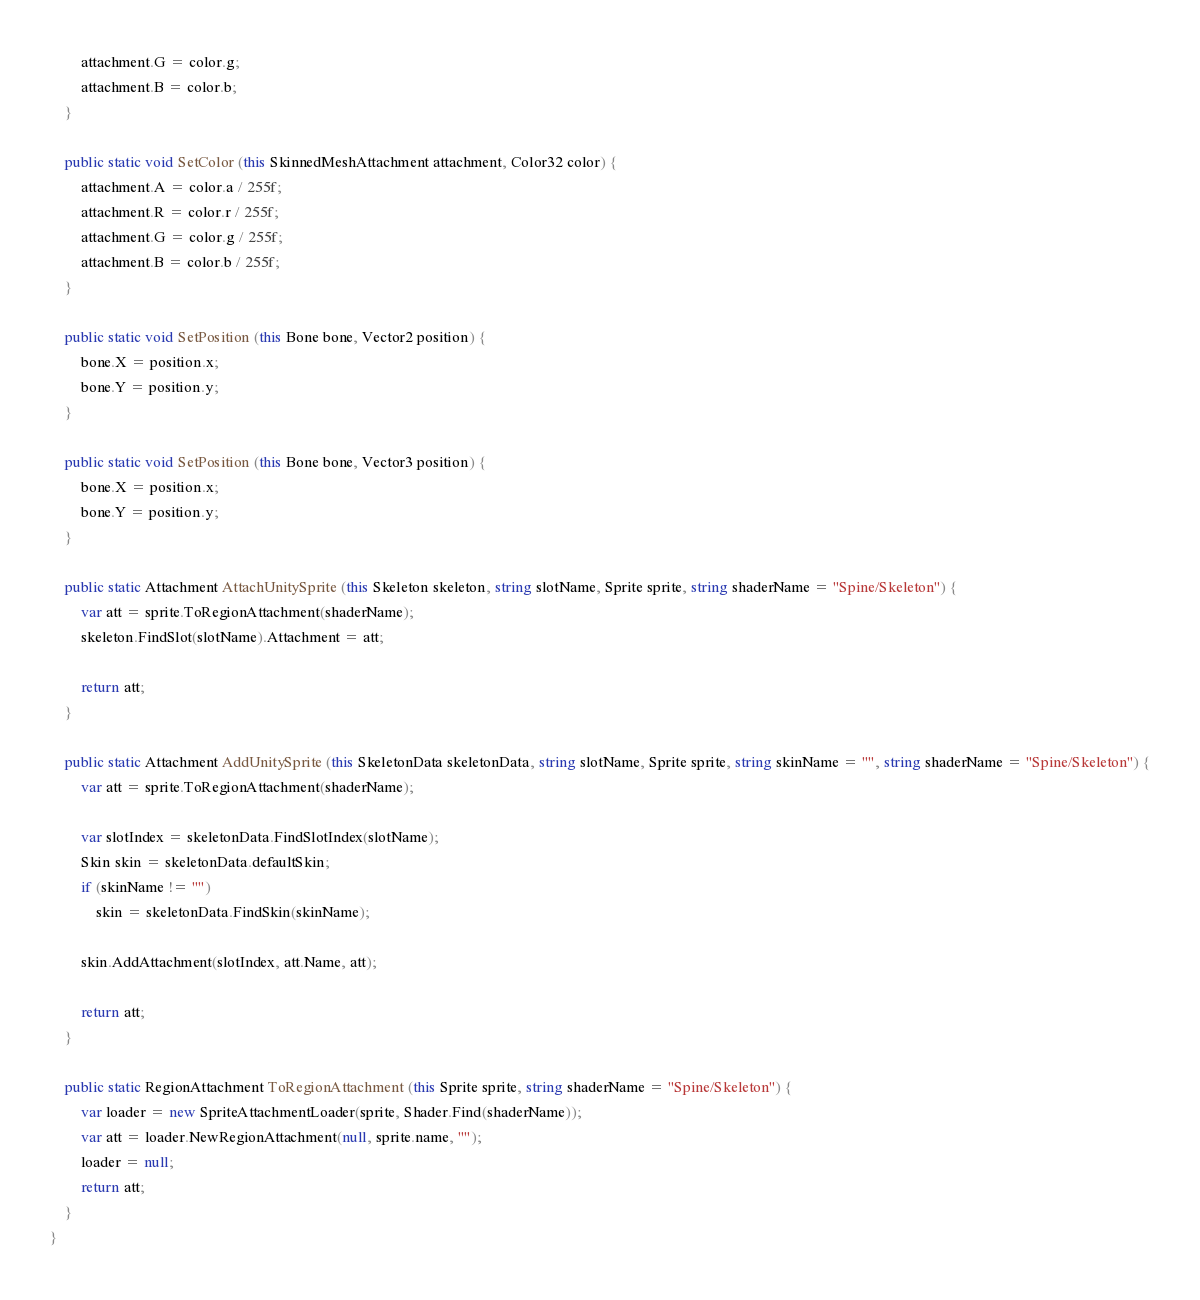<code> <loc_0><loc_0><loc_500><loc_500><_C#_>		attachment.G = color.g;
		attachment.B = color.b;
	}

	public static void SetColor (this SkinnedMeshAttachment attachment, Color32 color) {
		attachment.A = color.a / 255f;
		attachment.R = color.r / 255f;
		attachment.G = color.g / 255f;
		attachment.B = color.b / 255f;
	}

	public static void SetPosition (this Bone bone, Vector2 position) {
		bone.X = position.x;
		bone.Y = position.y;
	}

	public static void SetPosition (this Bone bone, Vector3 position) {
		bone.X = position.x;
		bone.Y = position.y;
	}

	public static Attachment AttachUnitySprite (this Skeleton skeleton, string slotName, Sprite sprite, string shaderName = "Spine/Skeleton") {
		var att = sprite.ToRegionAttachment(shaderName);
		skeleton.FindSlot(slotName).Attachment = att;

		return att;
	}

	public static Attachment AddUnitySprite (this SkeletonData skeletonData, string slotName, Sprite sprite, string skinName = "", string shaderName = "Spine/Skeleton") {
		var att = sprite.ToRegionAttachment(shaderName);

		var slotIndex = skeletonData.FindSlotIndex(slotName);
		Skin skin = skeletonData.defaultSkin;
		if (skinName != "")
			skin = skeletonData.FindSkin(skinName);

		skin.AddAttachment(slotIndex, att.Name, att);

		return att;
	}

	public static RegionAttachment ToRegionAttachment (this Sprite sprite, string shaderName = "Spine/Skeleton") {
		var loader = new SpriteAttachmentLoader(sprite, Shader.Find(shaderName));
		var att = loader.NewRegionAttachment(null, sprite.name, "");
		loader = null;
		return att;
	}
}</code> 